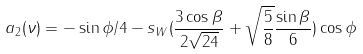Convert formula to latex. <formula><loc_0><loc_0><loc_500><loc_500>a _ { 2 } ( \nu ) = - \sin \phi / 4 - s _ { W } ( \frac { 3 \cos \beta } { 2 \sqrt { 2 4 } } + \sqrt { \frac { 5 } { 8 } } \frac { \sin \beta } { 6 } ) \cos \phi</formula> 